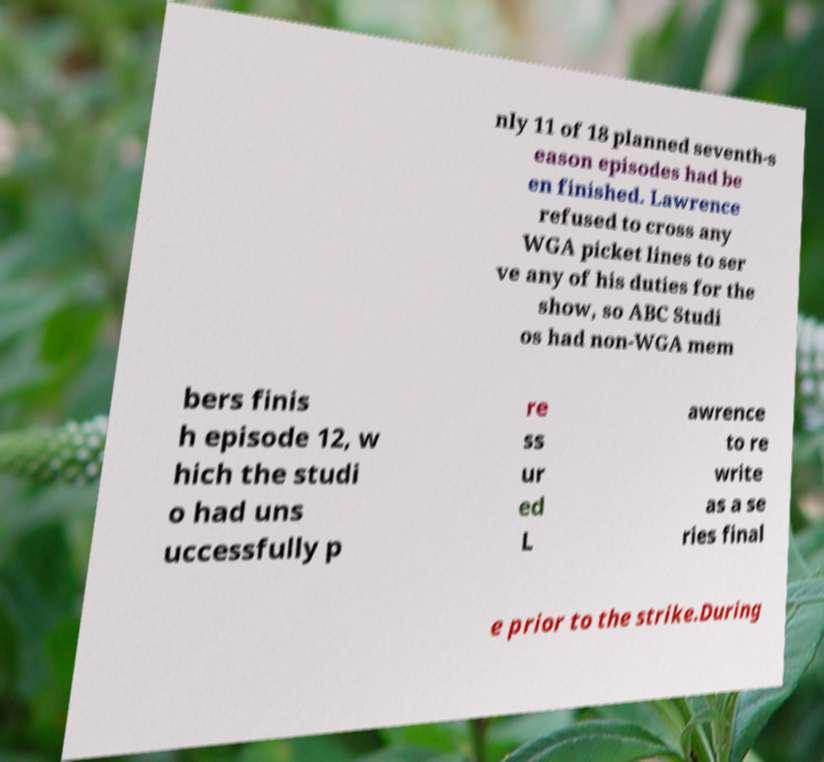Can you read and provide the text displayed in the image?This photo seems to have some interesting text. Can you extract and type it out for me? nly 11 of 18 planned seventh-s eason episodes had be en finished. Lawrence refused to cross any WGA picket lines to ser ve any of his duties for the show, so ABC Studi os had non-WGA mem bers finis h episode 12, w hich the studi o had uns uccessfully p re ss ur ed L awrence to re write as a se ries final e prior to the strike.During 